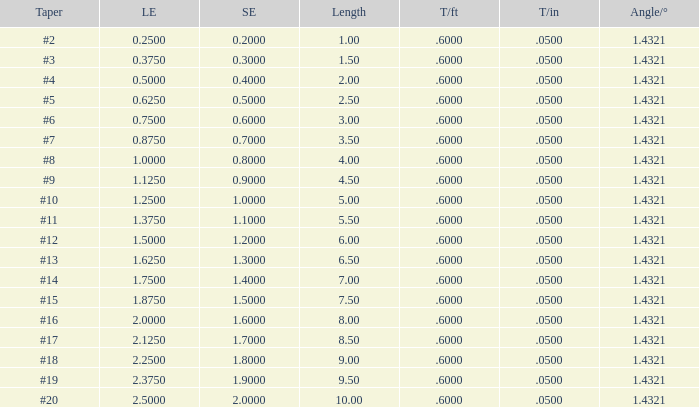Which Length has a Taper of #15, and a Large end larger than 1.875? None. 